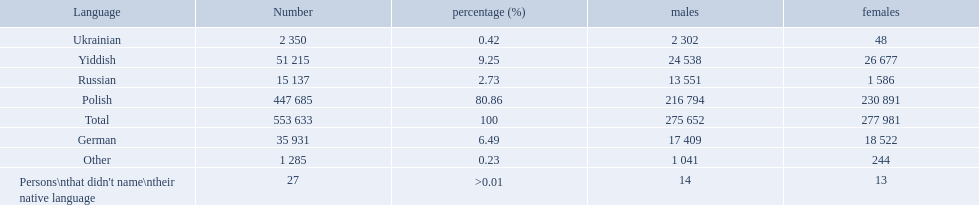Which language options are listed? Polish, Yiddish, German, Russian, Ukrainian, Other, Persons\nthat didn't name\ntheir native language. Of these, which did .42% of the people select? Ukrainian. 